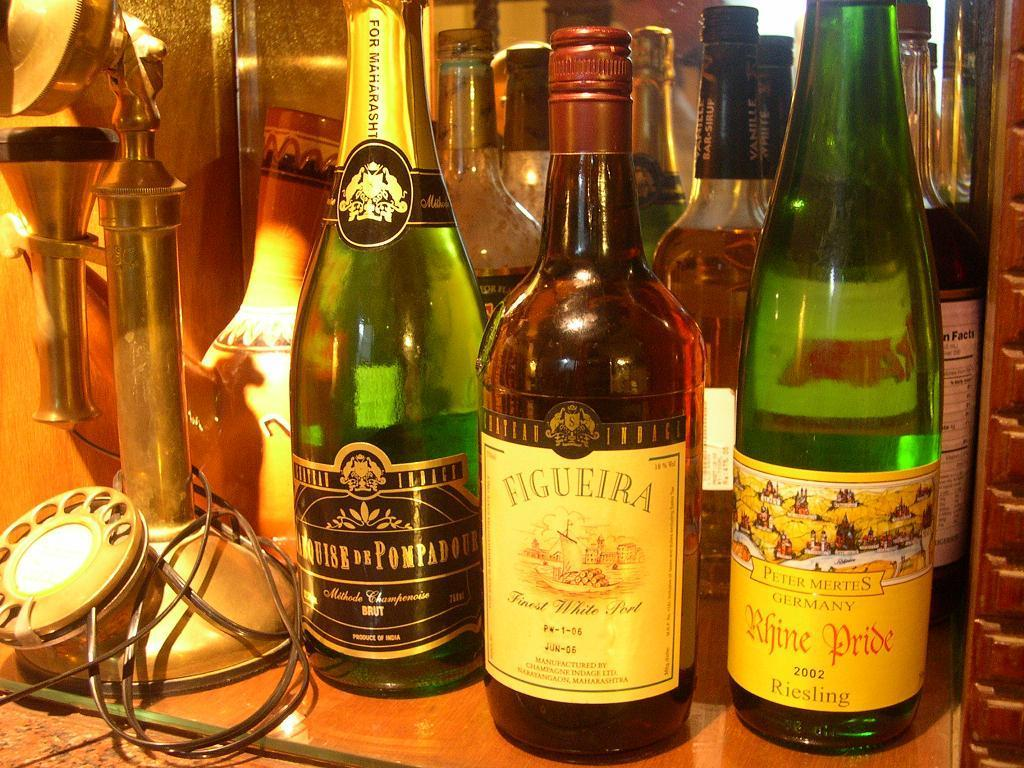What objects with different colors can be seen in the image? There are bottles with different colors in the image. Where is the telephone located in the image? The telephone is on the left side of the image. How does the arithmetic problem get solved in the image? There is no arithmetic problem present in the image, so it cannot be solved. 